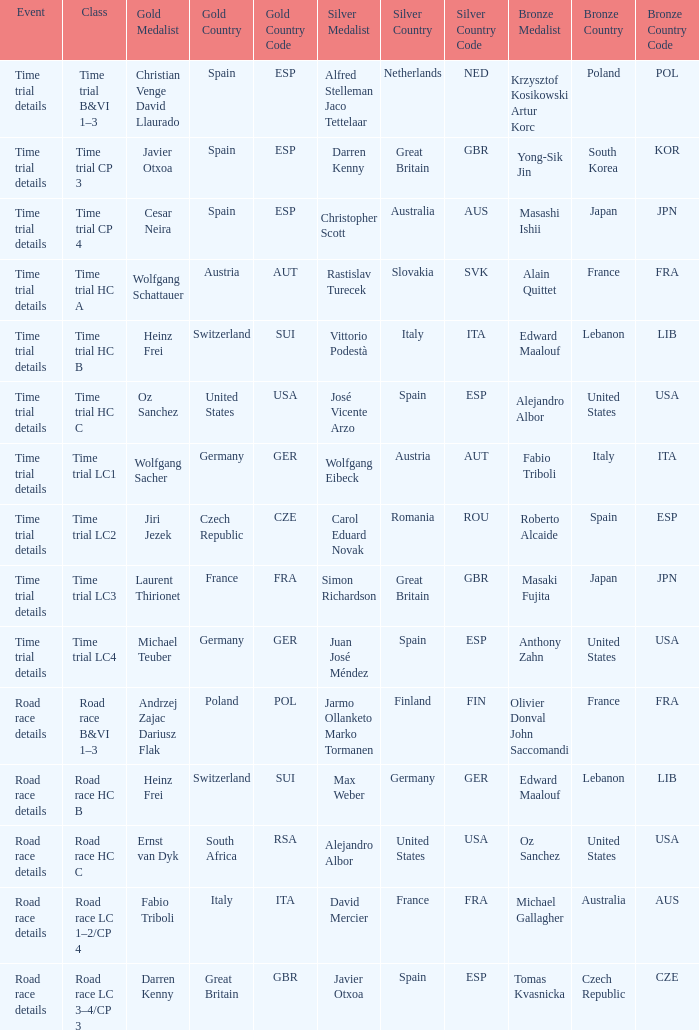Who received gold when the event is road race details and silver is max weber germany (ger)? Heinz Frei Switzerland (SUI). 